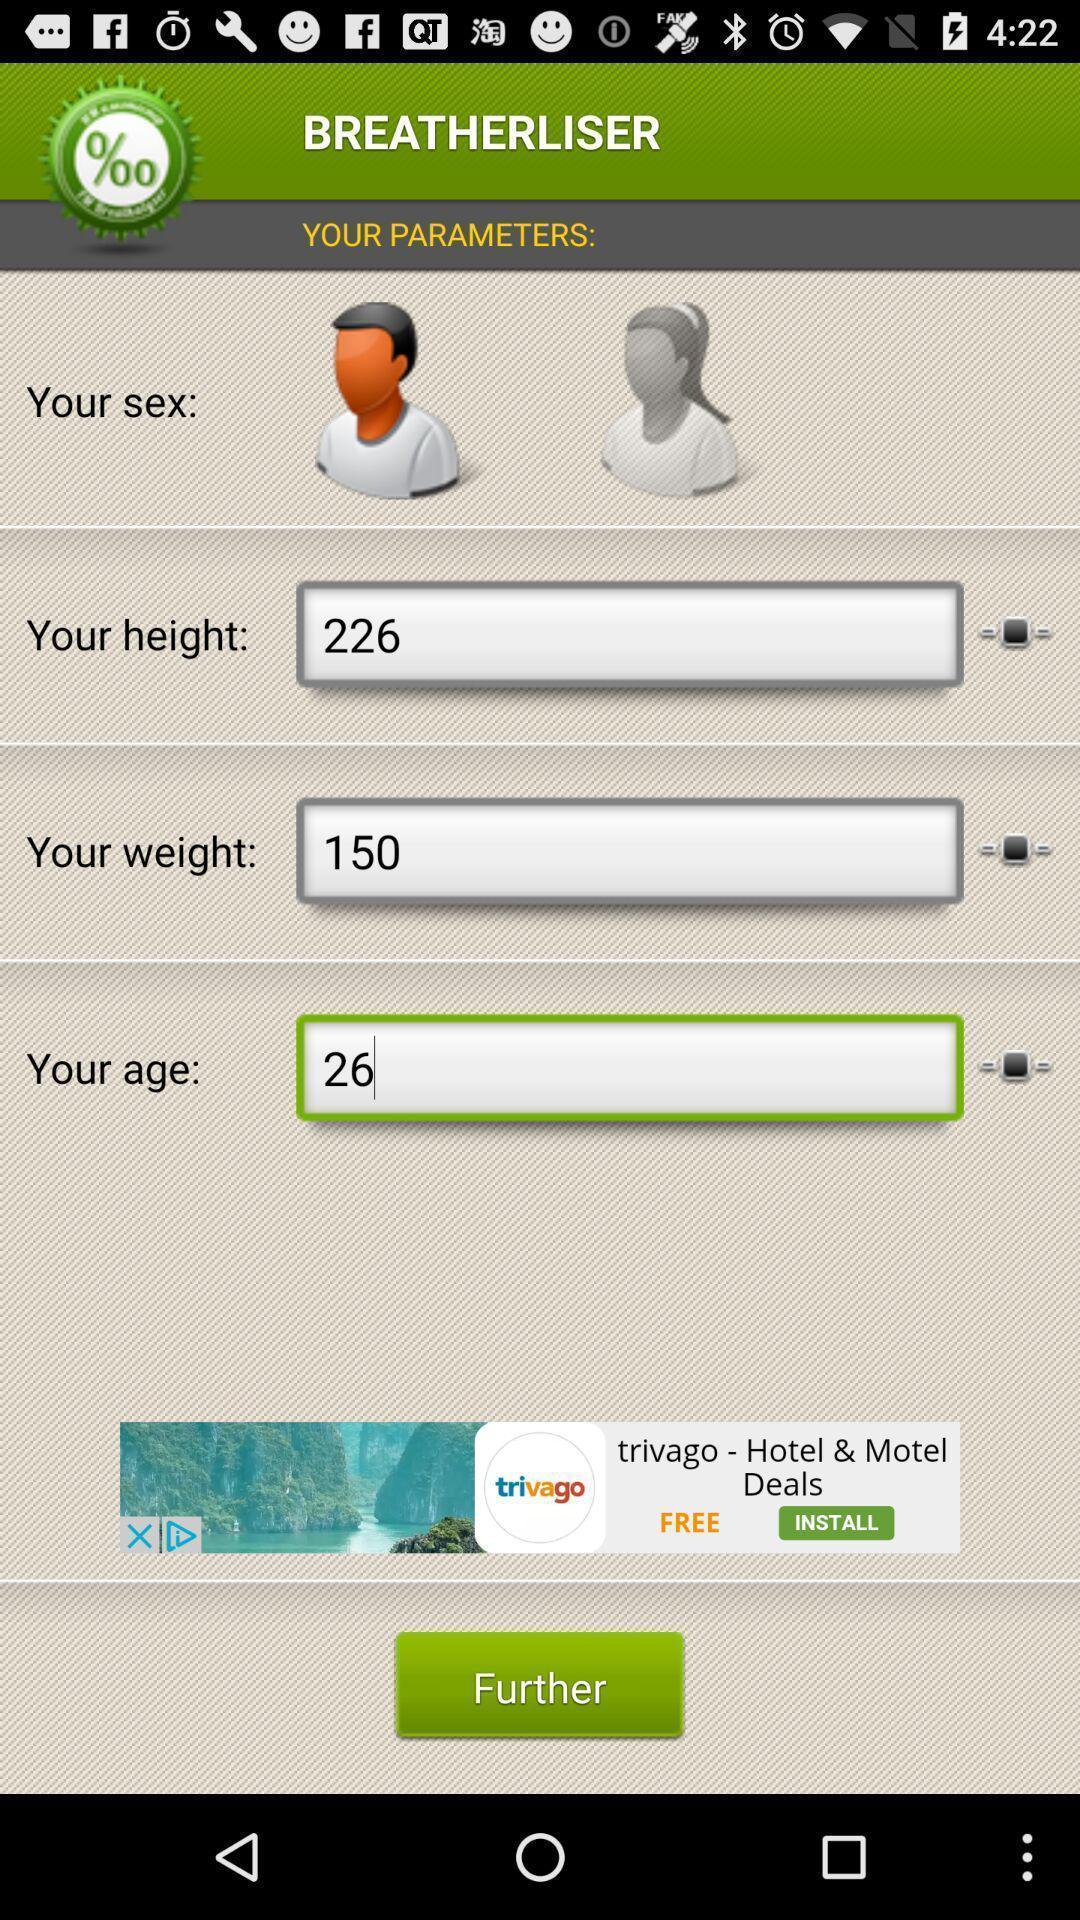Give me a summary of this screen capture. Page showing different parameters on a health care app. 